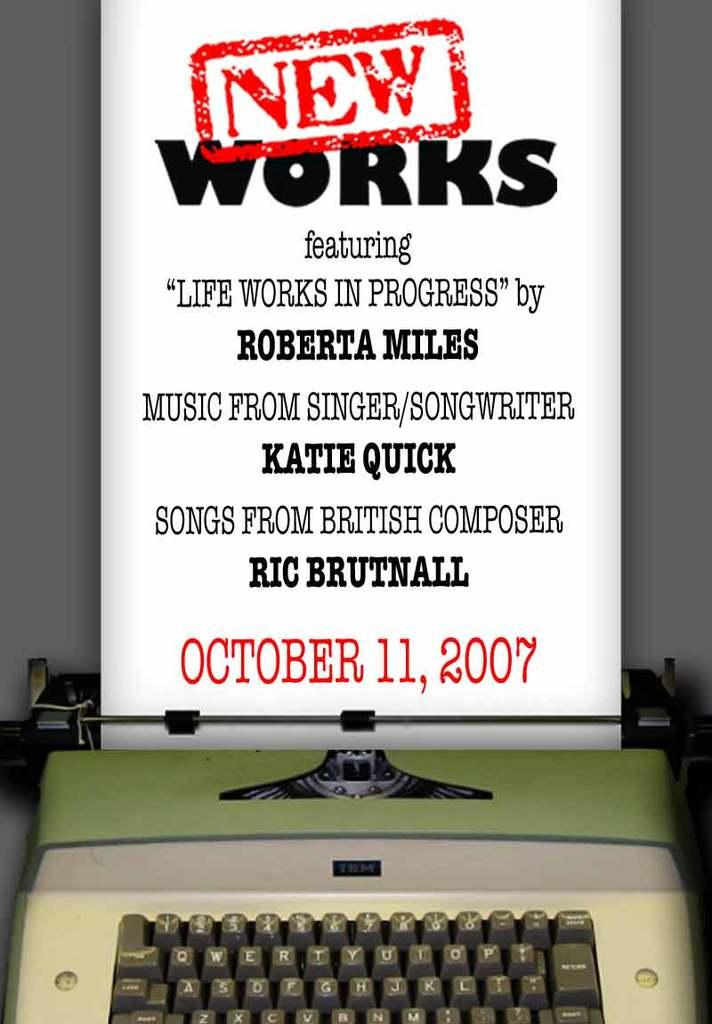<image>
Write a terse but informative summary of the picture. An ad that says New Works is coming out of a typewriter. 